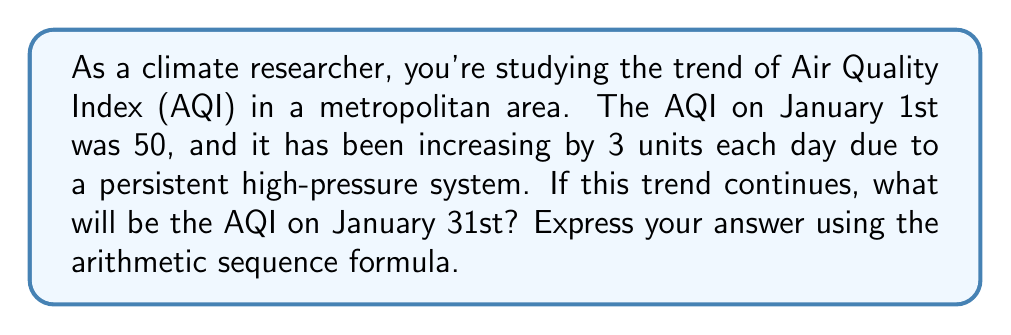Give your solution to this math problem. To solve this problem, we'll use the arithmetic sequence formula:

$$a_n = a_1 + (n-1)d$$

Where:
$a_n$ is the nth term (AQI on January 31st)
$a_1$ is the first term (AQI on January 1st = 50)
$n$ is the number of terms (number of days from Jan 1 to Jan 31 = 31)
$d$ is the common difference (daily increase = 3)

Step 1: Identify the values
$a_1 = 50$
$n = 31$
$d = 3$

Step 2: Substitute these values into the formula
$$a_{31} = 50 + (31-1)3$$

Step 3: Simplify
$$a_{31} = 50 + (30)(3)$$
$$a_{31} = 50 + 90$$
$$a_{31} = 140$$

Therefore, the AQI on January 31st will be 140.
Answer: $a_{31} = 50 + (31-1)3 = 140$ 